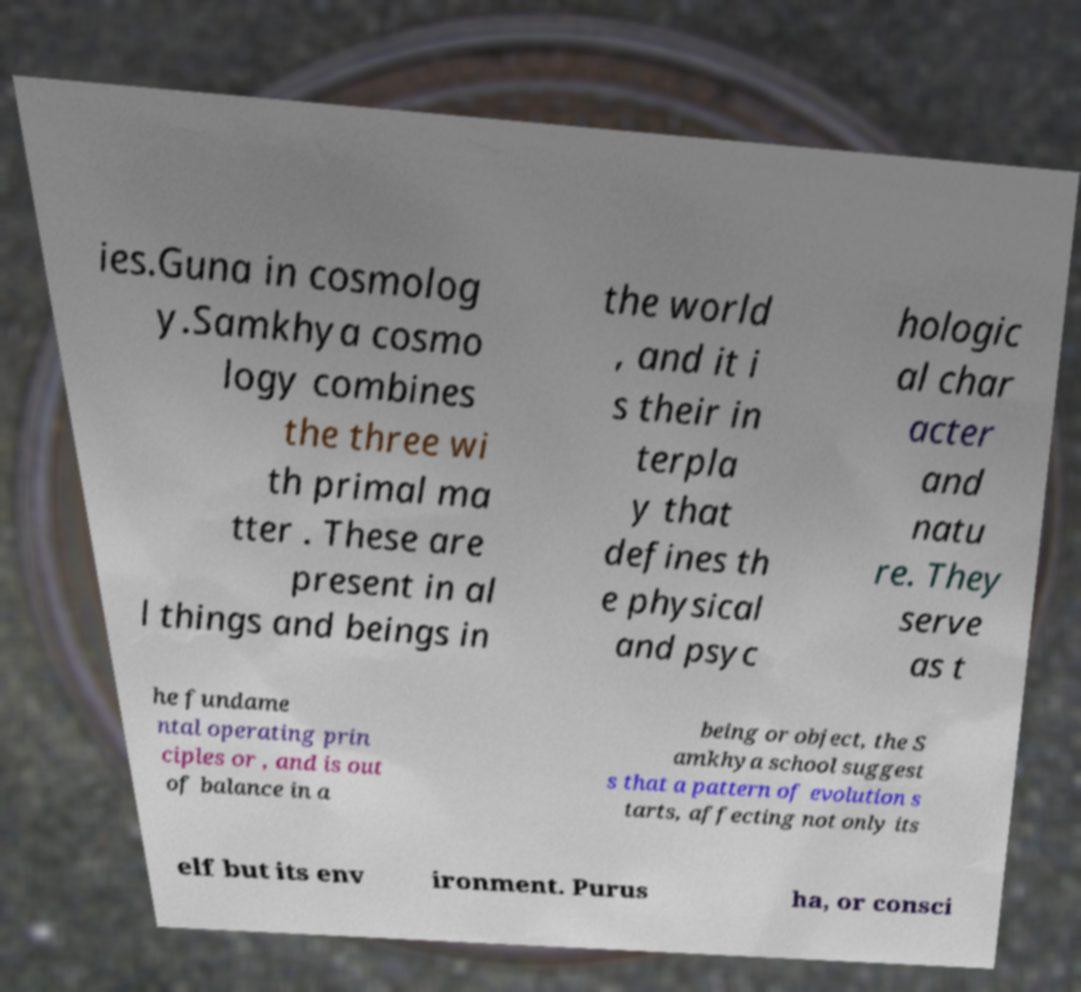Please read and relay the text visible in this image. What does it say? ies.Guna in cosmolog y.Samkhya cosmo logy combines the three wi th primal ma tter . These are present in al l things and beings in the world , and it i s their in terpla y that defines th e physical and psyc hologic al char acter and natu re. They serve as t he fundame ntal operating prin ciples or , and is out of balance in a being or object, the S amkhya school suggest s that a pattern of evolution s tarts, affecting not only its elf but its env ironment. Purus ha, or consci 